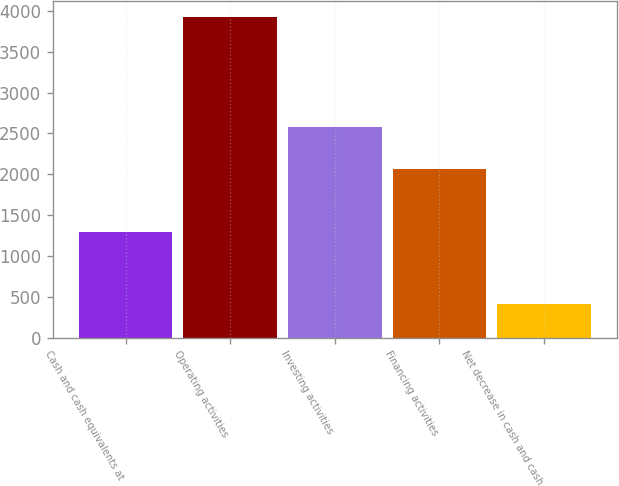Convert chart to OTSL. <chart><loc_0><loc_0><loc_500><loc_500><bar_chart><fcel>Cash and cash equivalents at<fcel>Operating activities<fcel>Investing activities<fcel>Financing activities<fcel>Net decrease in cash and cash<nl><fcel>1295<fcel>3926<fcel>2574<fcel>2061.1<fcel>415<nl></chart> 